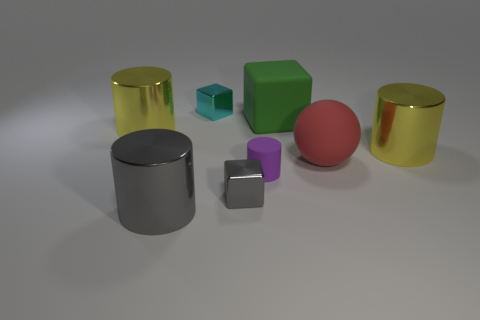What color is the big rubber cube?
Provide a succinct answer. Green. There is a green cube that is the same size as the red sphere; what material is it?
Provide a short and direct response. Rubber. There is a large yellow metallic cylinder that is to the left of the gray block; is there a large object left of it?
Provide a short and direct response. No. How big is the green rubber object?
Offer a terse response. Large. Are there any blue shiny things?
Provide a succinct answer. No. Are there more big things to the left of the small purple cylinder than red rubber objects in front of the large green block?
Your answer should be very brief. Yes. What is the cylinder that is both in front of the large red thing and behind the big gray thing made of?
Keep it short and to the point. Rubber. Do the small gray thing and the green matte object have the same shape?
Give a very brief answer. Yes. What number of metallic objects are left of the green matte thing?
Offer a very short reply. 4. Is the size of the shiny thing on the right side of the green block the same as the tiny gray thing?
Provide a succinct answer. No. 